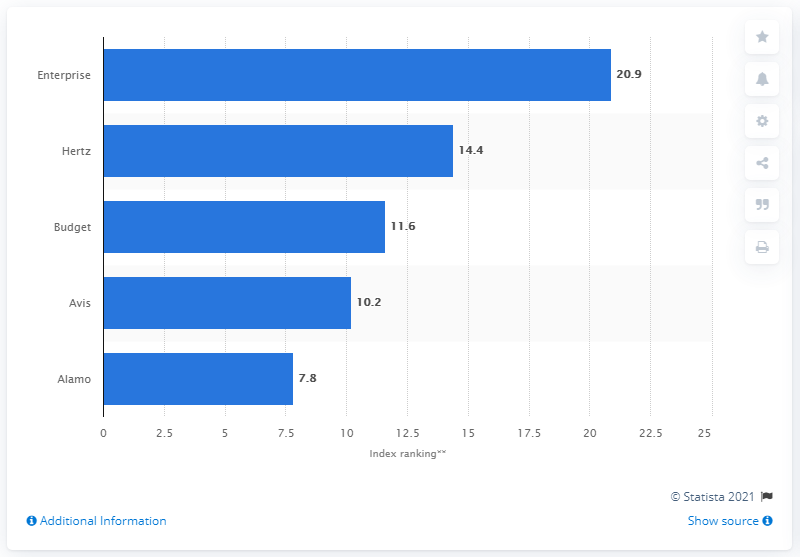Indicate a few pertinent items in this graphic. Hertz was ranked the highest among car rental companies in YouGov's brand index 2018. In YouGov's brand index 2018, Enterprise's score was 20.9. 